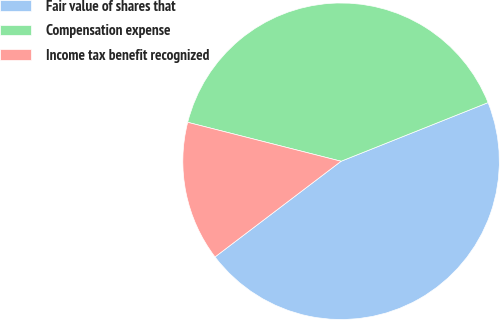<chart> <loc_0><loc_0><loc_500><loc_500><pie_chart><fcel>Fair value of shares that<fcel>Compensation expense<fcel>Income tax benefit recognized<nl><fcel>45.71%<fcel>40.0%<fcel>14.29%<nl></chart> 